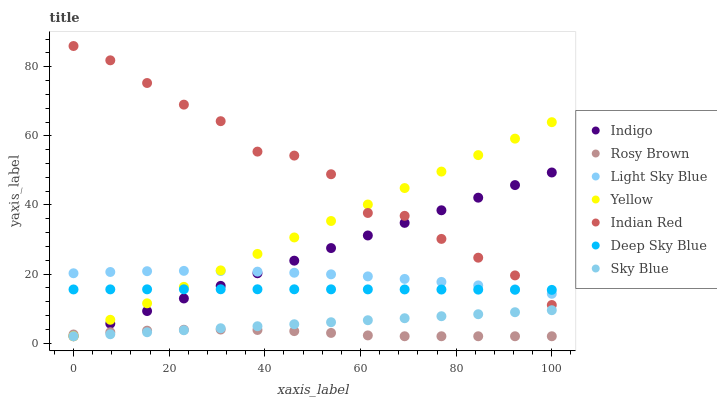Does Rosy Brown have the minimum area under the curve?
Answer yes or no. Yes. Does Indian Red have the maximum area under the curve?
Answer yes or no. Yes. Does Deep Sky Blue have the minimum area under the curve?
Answer yes or no. No. Does Deep Sky Blue have the maximum area under the curve?
Answer yes or no. No. Is Sky Blue the smoothest?
Answer yes or no. Yes. Is Indian Red the roughest?
Answer yes or no. Yes. Is Deep Sky Blue the smoothest?
Answer yes or no. No. Is Deep Sky Blue the roughest?
Answer yes or no. No. Does Indigo have the lowest value?
Answer yes or no. Yes. Does Deep Sky Blue have the lowest value?
Answer yes or no. No. Does Indian Red have the highest value?
Answer yes or no. Yes. Does Deep Sky Blue have the highest value?
Answer yes or no. No. Is Sky Blue less than Deep Sky Blue?
Answer yes or no. Yes. Is Light Sky Blue greater than Rosy Brown?
Answer yes or no. Yes. Does Light Sky Blue intersect Indigo?
Answer yes or no. Yes. Is Light Sky Blue less than Indigo?
Answer yes or no. No. Is Light Sky Blue greater than Indigo?
Answer yes or no. No. Does Sky Blue intersect Deep Sky Blue?
Answer yes or no. No. 